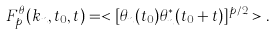<formula> <loc_0><loc_0><loc_500><loc_500>F ^ { \theta } _ { p } ( k _ { n } , t _ { 0 } , t ) = < [ \theta _ { n } ( t _ { 0 } ) \theta _ { n } ^ { * } ( t _ { 0 } + t ) ] ^ { p / 2 } > .</formula> 